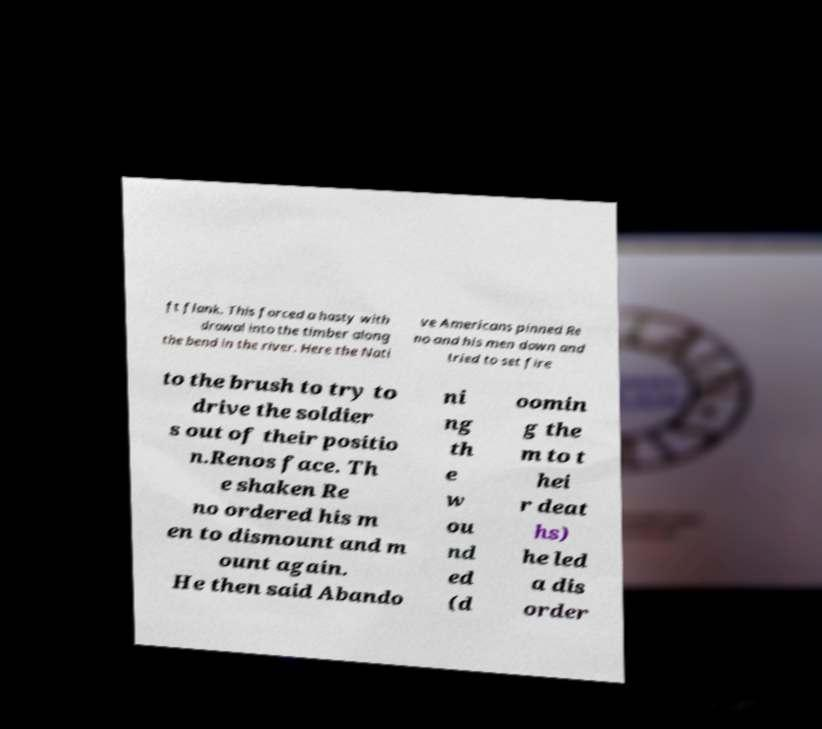What messages or text are displayed in this image? I need them in a readable, typed format. ft flank. This forced a hasty with drawal into the timber along the bend in the river. Here the Nati ve Americans pinned Re no and his men down and tried to set fire to the brush to try to drive the soldier s out of their positio n.Renos face. Th e shaken Re no ordered his m en to dismount and m ount again. He then said Abando ni ng th e w ou nd ed (d oomin g the m to t hei r deat hs) he led a dis order 